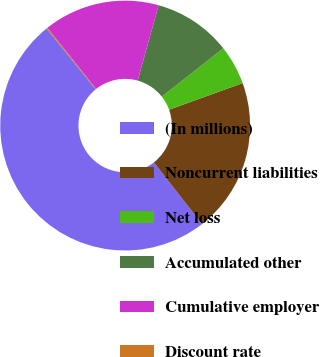<chart> <loc_0><loc_0><loc_500><loc_500><pie_chart><fcel>(In millions)<fcel>Noncurrent liabilities<fcel>Net loss<fcel>Accumulated other<fcel>Cumulative employer<fcel>Discount rate<nl><fcel>49.71%<fcel>19.97%<fcel>5.1%<fcel>10.06%<fcel>15.01%<fcel>0.14%<nl></chart> 